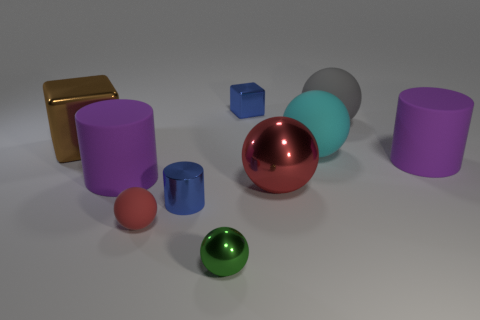Subtract all green shiny balls. How many balls are left? 4 Subtract all green balls. How many balls are left? 4 Subtract all brown balls. Subtract all red cubes. How many balls are left? 5 Subtract all blocks. How many objects are left? 8 Add 1 small cylinders. How many small cylinders are left? 2 Add 4 brown cubes. How many brown cubes exist? 5 Subtract 0 yellow blocks. How many objects are left? 10 Subtract all large red objects. Subtract all small red things. How many objects are left? 8 